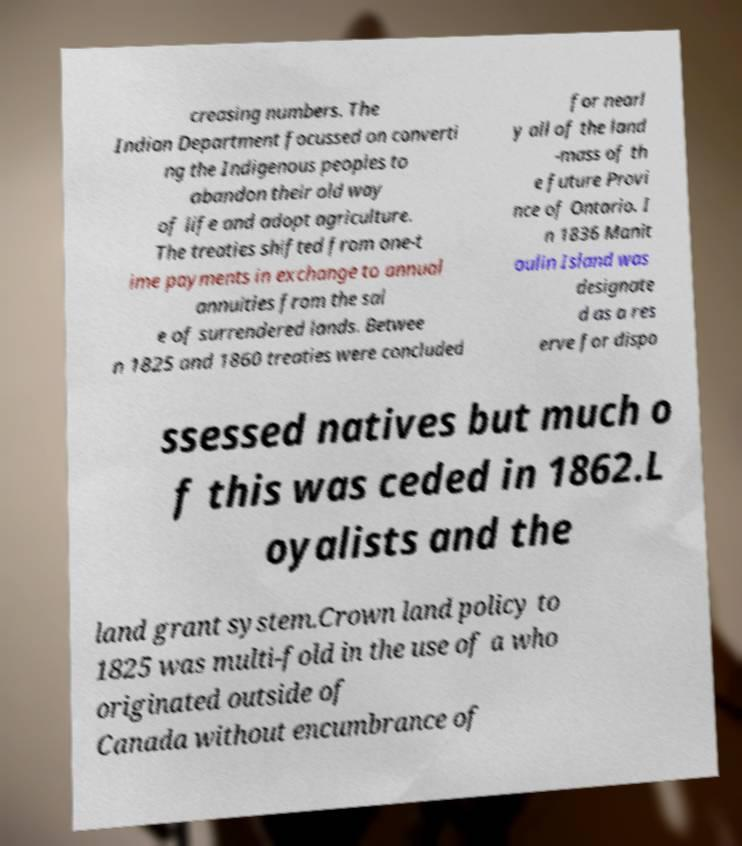Could you extract and type out the text from this image? creasing numbers. The Indian Department focussed on converti ng the Indigenous peoples to abandon their old way of life and adopt agriculture. The treaties shifted from one-t ime payments in exchange to annual annuities from the sal e of surrendered lands. Betwee n 1825 and 1860 treaties were concluded for nearl y all of the land -mass of th e future Provi nce of Ontario. I n 1836 Manit oulin Island was designate d as a res erve for dispo ssessed natives but much o f this was ceded in 1862.L oyalists and the land grant system.Crown land policy to 1825 was multi-fold in the use of a who originated outside of Canada without encumbrance of 